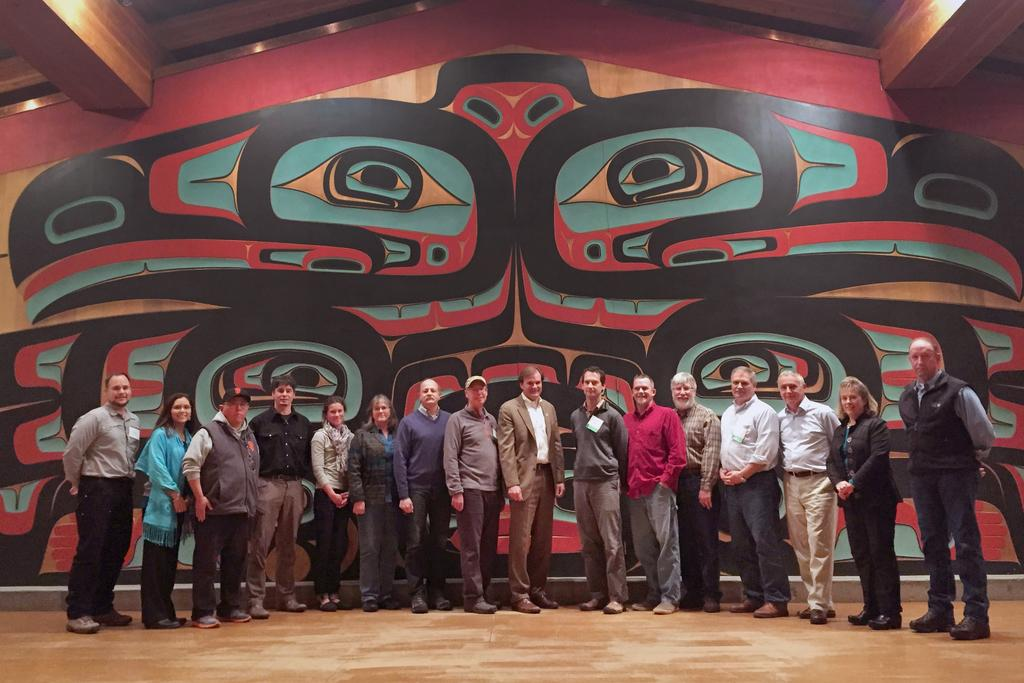Where might the image have been taken? The image might be taken inside a room. What can be seen on the floor in the image? There is a group of people standing on the floor. What is visible in the background of the image? There is a wall in the background of the image. What part of the room can be seen in the image? There is a roof visible in the image. How many patches are visible on the ladybug in the image? There is no ladybug present in the image, so it is not possible to determine the number of patches. 